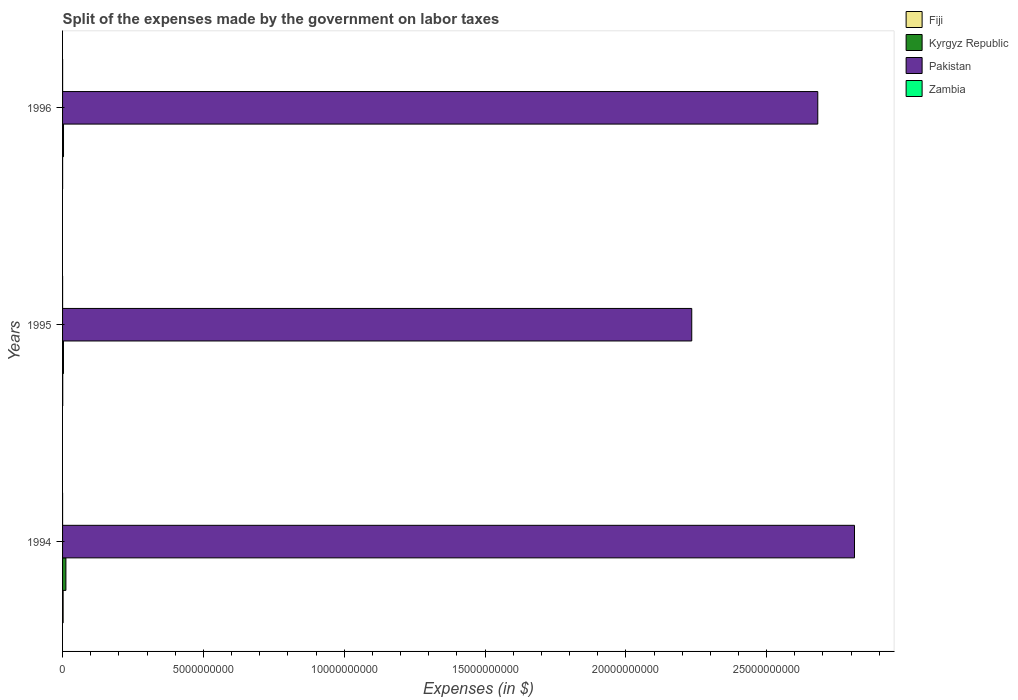How many different coloured bars are there?
Your response must be concise. 4. How many groups of bars are there?
Your answer should be compact. 3. Are the number of bars per tick equal to the number of legend labels?
Keep it short and to the point. Yes. How many bars are there on the 2nd tick from the top?
Offer a very short reply. 4. How many bars are there on the 1st tick from the bottom?
Make the answer very short. 4. What is the label of the 2nd group of bars from the top?
Keep it short and to the point. 1995. What is the expenses made by the government on labor taxes in Fiji in 1995?
Make the answer very short. 5.84e+06. Across all years, what is the maximum expenses made by the government on labor taxes in Fiji?
Your answer should be compact. 2.05e+07. Across all years, what is the minimum expenses made by the government on labor taxes in Fiji?
Make the answer very short. 1.69e+06. What is the total expenses made by the government on labor taxes in Kyrgyz Republic in the graph?
Keep it short and to the point. 1.84e+08. What is the difference between the expenses made by the government on labor taxes in Fiji in 1994 and that in 1996?
Provide a short and direct response. 1.88e+07. What is the difference between the expenses made by the government on labor taxes in Zambia in 1994 and the expenses made by the government on labor taxes in Pakistan in 1996?
Your answer should be very brief. -2.68e+1. What is the average expenses made by the government on labor taxes in Kyrgyz Republic per year?
Your answer should be very brief. 6.14e+07. In the year 1996, what is the difference between the expenses made by the government on labor taxes in Fiji and expenses made by the government on labor taxes in Pakistan?
Your response must be concise. -2.68e+1. What is the ratio of the expenses made by the government on labor taxes in Kyrgyz Republic in 1994 to that in 1995?
Make the answer very short. 3.68. Is the expenses made by the government on labor taxes in Pakistan in 1994 less than that in 1995?
Offer a very short reply. No. What is the difference between the highest and the second highest expenses made by the government on labor taxes in Fiji?
Make the answer very short. 1.46e+07. What is the difference between the highest and the lowest expenses made by the government on labor taxes in Kyrgyz Republic?
Ensure brevity in your answer.  8.62e+07. Is it the case that in every year, the sum of the expenses made by the government on labor taxes in Kyrgyz Republic and expenses made by the government on labor taxes in Fiji is greater than the sum of expenses made by the government on labor taxes in Pakistan and expenses made by the government on labor taxes in Zambia?
Give a very brief answer. No. What does the 2nd bar from the top in 1996 represents?
Ensure brevity in your answer.  Pakistan. What does the 4th bar from the bottom in 1994 represents?
Keep it short and to the point. Zambia. Are all the bars in the graph horizontal?
Your answer should be compact. Yes. How many years are there in the graph?
Give a very brief answer. 3. Does the graph contain any zero values?
Your answer should be very brief. No. Does the graph contain grids?
Make the answer very short. No. What is the title of the graph?
Provide a short and direct response. Split of the expenses made by the government on labor taxes. What is the label or title of the X-axis?
Your answer should be compact. Expenses (in $). What is the label or title of the Y-axis?
Provide a succinct answer. Years. What is the Expenses (in $) in Fiji in 1994?
Keep it short and to the point. 2.05e+07. What is the Expenses (in $) in Kyrgyz Republic in 1994?
Provide a succinct answer. 1.18e+08. What is the Expenses (in $) of Pakistan in 1994?
Make the answer very short. 2.81e+1. What is the Expenses (in $) in Zambia in 1994?
Keep it short and to the point. 6.33e+05. What is the Expenses (in $) of Fiji in 1995?
Your response must be concise. 5.84e+06. What is the Expenses (in $) of Kyrgyz Republic in 1995?
Make the answer very short. 3.22e+07. What is the Expenses (in $) of Pakistan in 1995?
Your answer should be compact. 2.23e+1. What is the Expenses (in $) in Zambia in 1995?
Your answer should be very brief. 9.35e+05. What is the Expenses (in $) in Fiji in 1996?
Make the answer very short. 1.69e+06. What is the Expenses (in $) of Kyrgyz Republic in 1996?
Your answer should be compact. 3.35e+07. What is the Expenses (in $) of Pakistan in 1996?
Offer a very short reply. 2.68e+1. What is the Expenses (in $) in Zambia in 1996?
Ensure brevity in your answer.  1.40e+06. Across all years, what is the maximum Expenses (in $) in Fiji?
Your response must be concise. 2.05e+07. Across all years, what is the maximum Expenses (in $) of Kyrgyz Republic?
Provide a succinct answer. 1.18e+08. Across all years, what is the maximum Expenses (in $) in Pakistan?
Make the answer very short. 2.81e+1. Across all years, what is the maximum Expenses (in $) of Zambia?
Offer a very short reply. 1.40e+06. Across all years, what is the minimum Expenses (in $) of Fiji?
Offer a terse response. 1.69e+06. Across all years, what is the minimum Expenses (in $) in Kyrgyz Republic?
Your response must be concise. 3.22e+07. Across all years, what is the minimum Expenses (in $) of Pakistan?
Your answer should be very brief. 2.23e+1. Across all years, what is the minimum Expenses (in $) in Zambia?
Give a very brief answer. 6.33e+05. What is the total Expenses (in $) in Fiji in the graph?
Your answer should be compact. 2.80e+07. What is the total Expenses (in $) of Kyrgyz Republic in the graph?
Provide a succinct answer. 1.84e+08. What is the total Expenses (in $) in Pakistan in the graph?
Provide a short and direct response. 7.73e+1. What is the total Expenses (in $) in Zambia in the graph?
Provide a short and direct response. 2.97e+06. What is the difference between the Expenses (in $) of Fiji in 1994 and that in 1995?
Give a very brief answer. 1.46e+07. What is the difference between the Expenses (in $) of Kyrgyz Republic in 1994 and that in 1995?
Provide a short and direct response. 8.62e+07. What is the difference between the Expenses (in $) of Pakistan in 1994 and that in 1995?
Offer a very short reply. 5.78e+09. What is the difference between the Expenses (in $) in Zambia in 1994 and that in 1995?
Your answer should be compact. -3.02e+05. What is the difference between the Expenses (in $) of Fiji in 1994 and that in 1996?
Give a very brief answer. 1.88e+07. What is the difference between the Expenses (in $) in Kyrgyz Republic in 1994 and that in 1996?
Give a very brief answer. 8.49e+07. What is the difference between the Expenses (in $) of Pakistan in 1994 and that in 1996?
Give a very brief answer. 1.30e+09. What is the difference between the Expenses (in $) in Zambia in 1994 and that in 1996?
Your answer should be very brief. -7.67e+05. What is the difference between the Expenses (in $) in Fiji in 1995 and that in 1996?
Ensure brevity in your answer.  4.15e+06. What is the difference between the Expenses (in $) of Kyrgyz Republic in 1995 and that in 1996?
Give a very brief answer. -1.34e+06. What is the difference between the Expenses (in $) of Pakistan in 1995 and that in 1996?
Your response must be concise. -4.48e+09. What is the difference between the Expenses (in $) in Zambia in 1995 and that in 1996?
Your response must be concise. -4.65e+05. What is the difference between the Expenses (in $) in Fiji in 1994 and the Expenses (in $) in Kyrgyz Republic in 1995?
Provide a short and direct response. -1.17e+07. What is the difference between the Expenses (in $) in Fiji in 1994 and the Expenses (in $) in Pakistan in 1995?
Offer a very short reply. -2.23e+1. What is the difference between the Expenses (in $) of Fiji in 1994 and the Expenses (in $) of Zambia in 1995?
Your response must be concise. 1.95e+07. What is the difference between the Expenses (in $) in Kyrgyz Republic in 1994 and the Expenses (in $) in Pakistan in 1995?
Make the answer very short. -2.22e+1. What is the difference between the Expenses (in $) in Kyrgyz Republic in 1994 and the Expenses (in $) in Zambia in 1995?
Offer a very short reply. 1.17e+08. What is the difference between the Expenses (in $) in Pakistan in 1994 and the Expenses (in $) in Zambia in 1995?
Your response must be concise. 2.81e+1. What is the difference between the Expenses (in $) in Fiji in 1994 and the Expenses (in $) in Kyrgyz Republic in 1996?
Your answer should be very brief. -1.31e+07. What is the difference between the Expenses (in $) of Fiji in 1994 and the Expenses (in $) of Pakistan in 1996?
Your answer should be very brief. -2.68e+1. What is the difference between the Expenses (in $) in Fiji in 1994 and the Expenses (in $) in Zambia in 1996?
Your answer should be compact. 1.91e+07. What is the difference between the Expenses (in $) in Kyrgyz Republic in 1994 and the Expenses (in $) in Pakistan in 1996?
Your answer should be compact. -2.67e+1. What is the difference between the Expenses (in $) in Kyrgyz Republic in 1994 and the Expenses (in $) in Zambia in 1996?
Make the answer very short. 1.17e+08. What is the difference between the Expenses (in $) in Pakistan in 1994 and the Expenses (in $) in Zambia in 1996?
Give a very brief answer. 2.81e+1. What is the difference between the Expenses (in $) in Fiji in 1995 and the Expenses (in $) in Kyrgyz Republic in 1996?
Provide a short and direct response. -2.77e+07. What is the difference between the Expenses (in $) in Fiji in 1995 and the Expenses (in $) in Pakistan in 1996?
Your response must be concise. -2.68e+1. What is the difference between the Expenses (in $) of Fiji in 1995 and the Expenses (in $) of Zambia in 1996?
Your response must be concise. 4.44e+06. What is the difference between the Expenses (in $) in Kyrgyz Republic in 1995 and the Expenses (in $) in Pakistan in 1996?
Your answer should be compact. -2.68e+1. What is the difference between the Expenses (in $) in Kyrgyz Republic in 1995 and the Expenses (in $) in Zambia in 1996?
Offer a terse response. 3.08e+07. What is the difference between the Expenses (in $) of Pakistan in 1995 and the Expenses (in $) of Zambia in 1996?
Provide a short and direct response. 2.23e+1. What is the average Expenses (in $) of Fiji per year?
Ensure brevity in your answer.  9.33e+06. What is the average Expenses (in $) of Kyrgyz Republic per year?
Ensure brevity in your answer.  6.14e+07. What is the average Expenses (in $) of Pakistan per year?
Offer a very short reply. 2.58e+1. What is the average Expenses (in $) in Zambia per year?
Make the answer very short. 9.90e+05. In the year 1994, what is the difference between the Expenses (in $) in Fiji and Expenses (in $) in Kyrgyz Republic?
Offer a very short reply. -9.79e+07. In the year 1994, what is the difference between the Expenses (in $) in Fiji and Expenses (in $) in Pakistan?
Keep it short and to the point. -2.81e+1. In the year 1994, what is the difference between the Expenses (in $) of Fiji and Expenses (in $) of Zambia?
Offer a terse response. 1.98e+07. In the year 1994, what is the difference between the Expenses (in $) in Kyrgyz Republic and Expenses (in $) in Pakistan?
Your response must be concise. -2.80e+1. In the year 1994, what is the difference between the Expenses (in $) in Kyrgyz Republic and Expenses (in $) in Zambia?
Keep it short and to the point. 1.18e+08. In the year 1994, what is the difference between the Expenses (in $) in Pakistan and Expenses (in $) in Zambia?
Provide a succinct answer. 2.81e+1. In the year 1995, what is the difference between the Expenses (in $) of Fiji and Expenses (in $) of Kyrgyz Republic?
Your answer should be very brief. -2.64e+07. In the year 1995, what is the difference between the Expenses (in $) of Fiji and Expenses (in $) of Pakistan?
Provide a succinct answer. -2.23e+1. In the year 1995, what is the difference between the Expenses (in $) in Fiji and Expenses (in $) in Zambia?
Your response must be concise. 4.90e+06. In the year 1995, what is the difference between the Expenses (in $) in Kyrgyz Republic and Expenses (in $) in Pakistan?
Give a very brief answer. -2.23e+1. In the year 1995, what is the difference between the Expenses (in $) in Kyrgyz Republic and Expenses (in $) in Zambia?
Keep it short and to the point. 3.13e+07. In the year 1995, what is the difference between the Expenses (in $) in Pakistan and Expenses (in $) in Zambia?
Make the answer very short. 2.23e+1. In the year 1996, what is the difference between the Expenses (in $) of Fiji and Expenses (in $) of Kyrgyz Republic?
Make the answer very short. -3.18e+07. In the year 1996, what is the difference between the Expenses (in $) in Fiji and Expenses (in $) in Pakistan?
Keep it short and to the point. -2.68e+1. In the year 1996, what is the difference between the Expenses (in $) of Fiji and Expenses (in $) of Zambia?
Provide a short and direct response. 2.90e+05. In the year 1996, what is the difference between the Expenses (in $) of Kyrgyz Republic and Expenses (in $) of Pakistan?
Ensure brevity in your answer.  -2.68e+1. In the year 1996, what is the difference between the Expenses (in $) in Kyrgyz Republic and Expenses (in $) in Zambia?
Your response must be concise. 3.21e+07. In the year 1996, what is the difference between the Expenses (in $) of Pakistan and Expenses (in $) of Zambia?
Keep it short and to the point. 2.68e+1. What is the ratio of the Expenses (in $) of Fiji in 1994 to that in 1995?
Give a very brief answer. 3.51. What is the ratio of the Expenses (in $) of Kyrgyz Republic in 1994 to that in 1995?
Make the answer very short. 3.68. What is the ratio of the Expenses (in $) in Pakistan in 1994 to that in 1995?
Provide a succinct answer. 1.26. What is the ratio of the Expenses (in $) of Zambia in 1994 to that in 1995?
Provide a succinct answer. 0.68. What is the ratio of the Expenses (in $) in Fiji in 1994 to that in 1996?
Your response must be concise. 12.11. What is the ratio of the Expenses (in $) in Kyrgyz Republic in 1994 to that in 1996?
Keep it short and to the point. 3.53. What is the ratio of the Expenses (in $) of Pakistan in 1994 to that in 1996?
Your answer should be compact. 1.05. What is the ratio of the Expenses (in $) in Zambia in 1994 to that in 1996?
Keep it short and to the point. 0.45. What is the ratio of the Expenses (in $) of Fiji in 1995 to that in 1996?
Make the answer very short. 3.46. What is the ratio of the Expenses (in $) of Kyrgyz Republic in 1995 to that in 1996?
Offer a terse response. 0.96. What is the ratio of the Expenses (in $) in Pakistan in 1995 to that in 1996?
Offer a terse response. 0.83. What is the ratio of the Expenses (in $) of Zambia in 1995 to that in 1996?
Your response must be concise. 0.67. What is the difference between the highest and the second highest Expenses (in $) of Fiji?
Ensure brevity in your answer.  1.46e+07. What is the difference between the highest and the second highest Expenses (in $) in Kyrgyz Republic?
Your answer should be compact. 8.49e+07. What is the difference between the highest and the second highest Expenses (in $) in Pakistan?
Offer a very short reply. 1.30e+09. What is the difference between the highest and the second highest Expenses (in $) of Zambia?
Give a very brief answer. 4.65e+05. What is the difference between the highest and the lowest Expenses (in $) in Fiji?
Offer a very short reply. 1.88e+07. What is the difference between the highest and the lowest Expenses (in $) in Kyrgyz Republic?
Offer a very short reply. 8.62e+07. What is the difference between the highest and the lowest Expenses (in $) of Pakistan?
Provide a short and direct response. 5.78e+09. What is the difference between the highest and the lowest Expenses (in $) of Zambia?
Your response must be concise. 7.67e+05. 